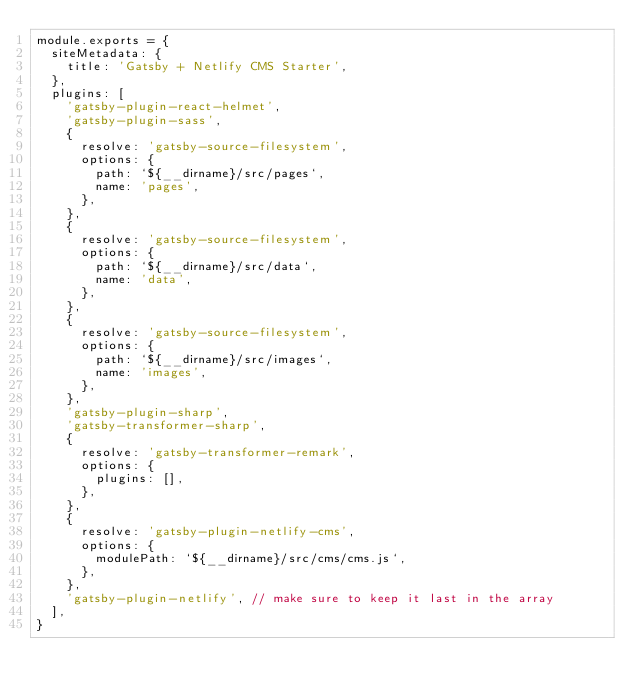<code> <loc_0><loc_0><loc_500><loc_500><_JavaScript_>module.exports = {
  siteMetadata: {
    title: 'Gatsby + Netlify CMS Starter',
  },
  plugins: [
    'gatsby-plugin-react-helmet',
    'gatsby-plugin-sass',
    {
      resolve: 'gatsby-source-filesystem',
      options: {
        path: `${__dirname}/src/pages`,
        name: 'pages',
      },
    },
    {
      resolve: 'gatsby-source-filesystem',
      options: {
        path: `${__dirname}/src/data`,
        name: 'data',
      },
    },
    {
      resolve: 'gatsby-source-filesystem',
      options: {
        path: `${__dirname}/src/images`,
        name: 'images',
      },
    },
    'gatsby-plugin-sharp',
    'gatsby-transformer-sharp',
    {
      resolve: 'gatsby-transformer-remark',
      options: {
        plugins: [],
      },
    },
    {
      resolve: 'gatsby-plugin-netlify-cms',
      options: {
        modulePath: `${__dirname}/src/cms/cms.js`,
      },
    },
    'gatsby-plugin-netlify', // make sure to keep it last in the array
  ],
}
</code> 